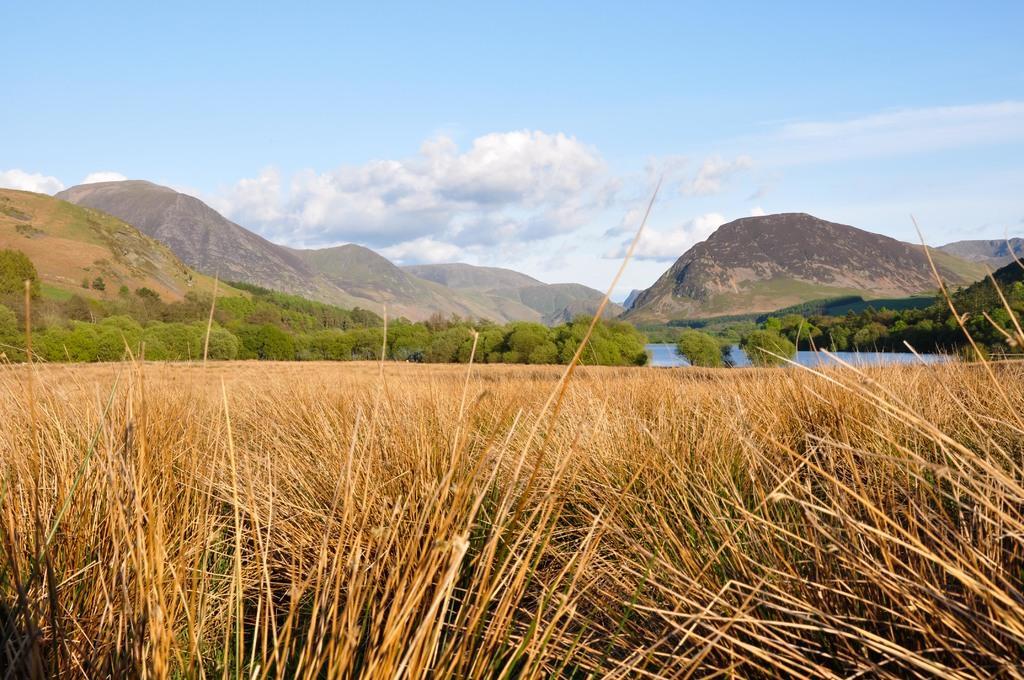Please provide a concise description of this image. In this image we can see the dry grass, trees, water, hills and the sky with clouds in the background. 